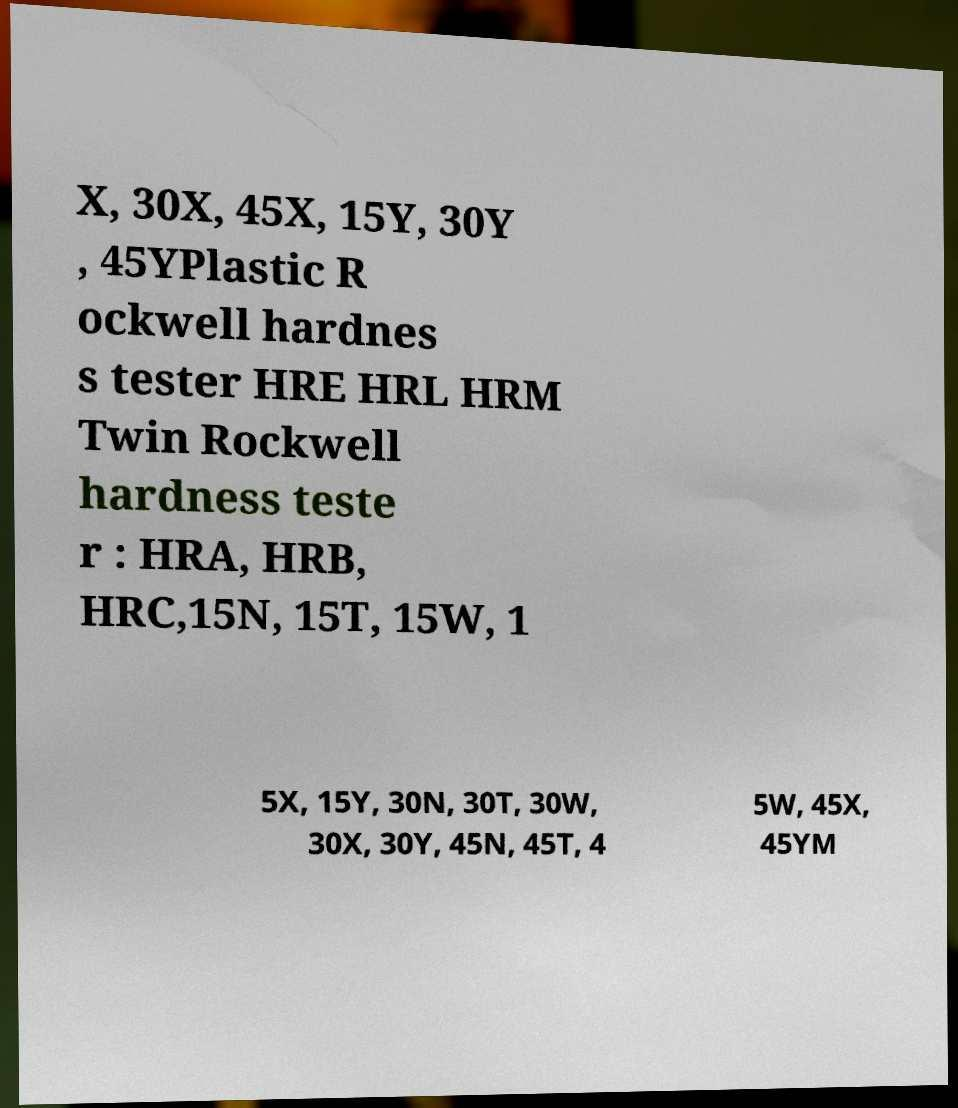There's text embedded in this image that I need extracted. Can you transcribe it verbatim? X, 30X, 45X, 15Y, 30Y , 45YPlastic R ockwell hardnes s tester HRE HRL HRM Twin Rockwell hardness teste r : HRA, HRB, HRC,15N, 15T, 15W, 1 5X, 15Y, 30N, 30T, 30W, 30X, 30Y, 45N, 45T, 4 5W, 45X, 45YM 